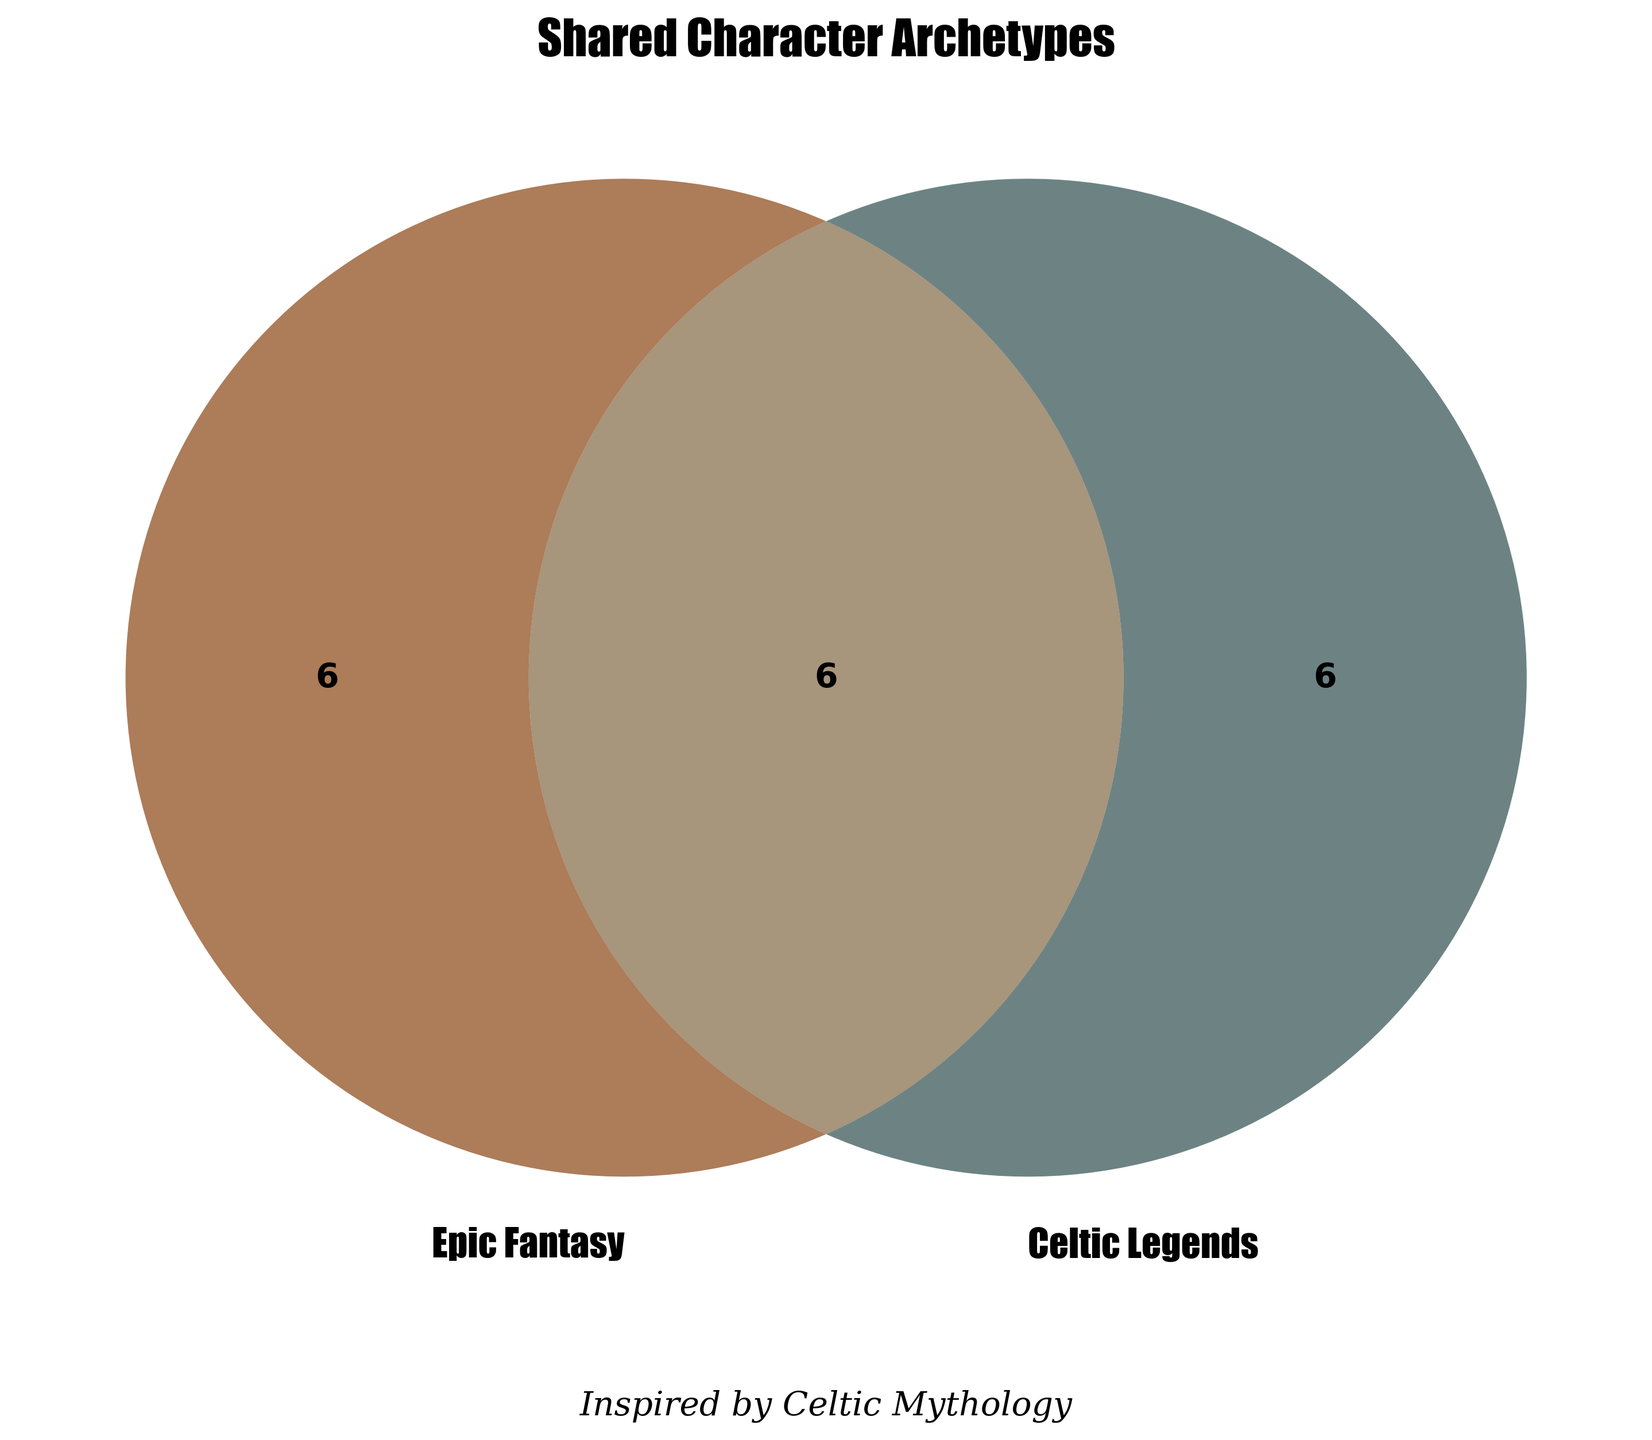What are the shared character archetypes between Epic Fantasy and Celtic Legends? The overlap in the Venn Diagram represents shared character archetypes. These include characters that appear in both Epic Fantasy and Celtic Legends.
Answer: Hero's Journey, Wise Mentor, Prophecies, Quests, Magic Users, Sacred Objects What character archetypes are unique to Celtic Legends? The right circle in the Venn Diagram displays character archetypes unique to Celtic Legends.
Answer: Shapeshifters, Druids, Sidhe (Fairies), Warrior Queens, Bards, Trickster Gods How many character archetypes are exclusive to Epic Fantasy? The left circle in the Venn Diagram represents character archetypes exclusive to Epic Fantasy. Count each unique archetype.
Answer: 6 Which character archetypes are exclusive to Epic Fantasy? The left circle in the Venn Diagram shows character archetypes unique to Epic Fantasy.
Answer: Chosen One, Dark Lord, Magical Creatures, Enchanted Weapons, Fantasy Races, Epic Battles Which side has more unique character archetypes, Epic Fantasy or Celtic Legends? Count the number of character archetypes in each unique section. Epic Fantasy has 6, and Celtic Legends also have 6.
Answer: Equal How many total character archetypes are there combining all categories? Add up the unique Epic Fantasy, unique Celtic Legends, and shared character archetypes. 6 (Epic Fantasy) + 6 (Celtic Legends) + 6 (Both) = 18
Answer: 18 What is the title of the Venn Diagram? The title is usually located at the top of the figure.
Answer: Shared Character Archetypes What archetype is shared between Epic Fantasy and Celtic Legends involving a journey? Check the shared section of the Venn Diagram for any archetype related to a journey.
Answer: Hero's Journey 